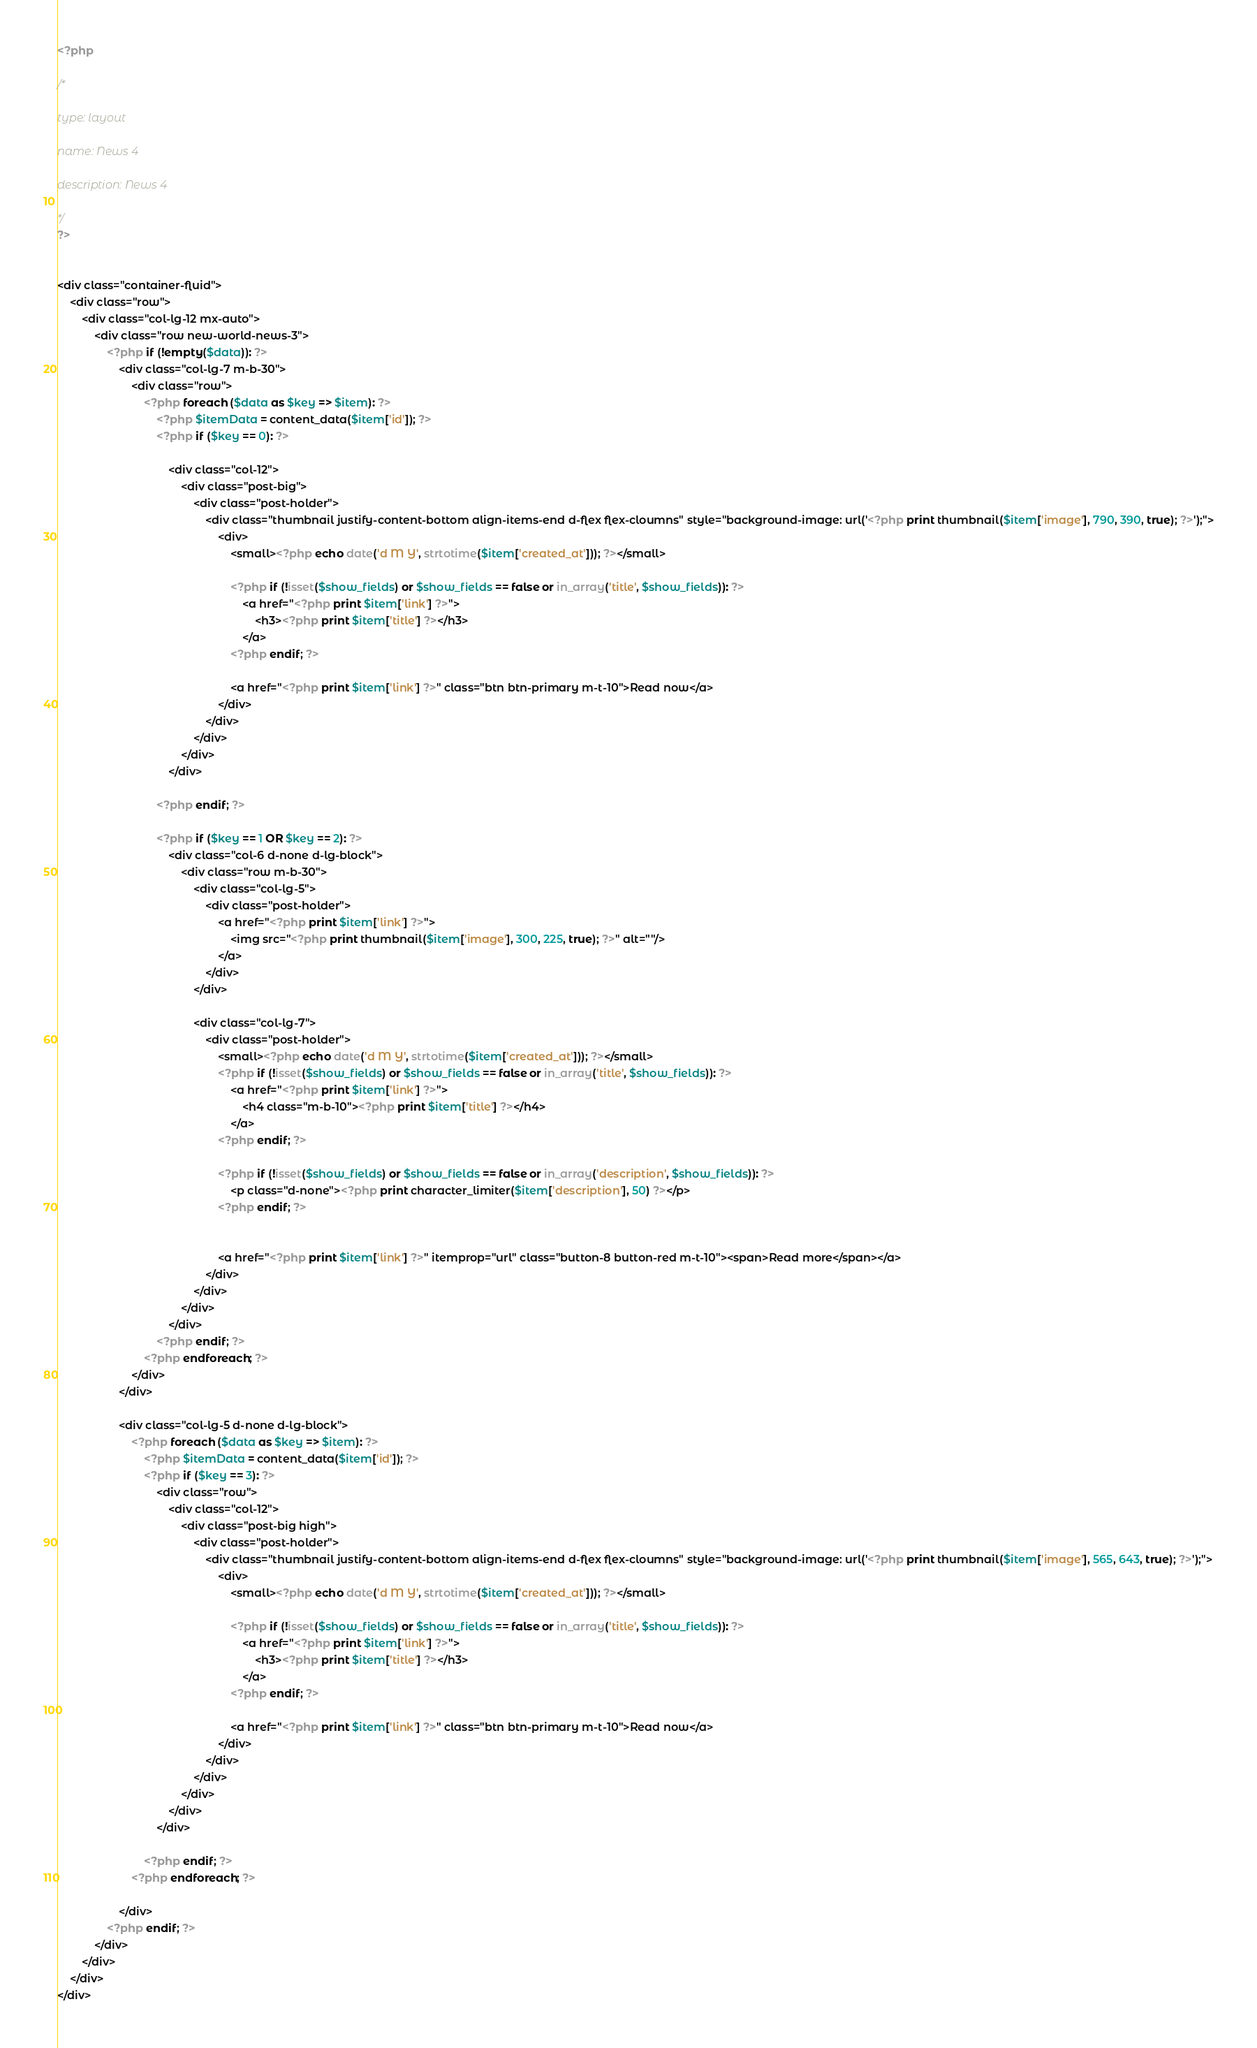Convert code to text. <code><loc_0><loc_0><loc_500><loc_500><_PHP_><?php

/*

type: layout

name: News 4

description: News 4

*/
?>


<div class="container-fluid">
    <div class="row">
        <div class="col-lg-12 mx-auto">
            <div class="row new-world-news-3">
                <?php if (!empty($data)): ?>
                    <div class="col-lg-7 m-b-30">
                        <div class="row">
                            <?php foreach ($data as $key => $item): ?>
                                <?php $itemData = content_data($item['id']); ?>
                                <?php if ($key == 0): ?>

                                    <div class="col-12">
                                        <div class="post-big">
                                            <div class="post-holder">
                                                <div class="thumbnail justify-content-bottom align-items-end d-flex flex-cloumns" style="background-image: url('<?php print thumbnail($item['image'], 790, 390, true); ?>');">
                                                    <div>
                                                        <small><?php echo date('d M Y', strtotime($item['created_at'])); ?></small>

                                                        <?php if (!isset($show_fields) or $show_fields == false or in_array('title', $show_fields)): ?>
                                                            <a href="<?php print $item['link'] ?>">
                                                                <h3><?php print $item['title'] ?></h3>
                                                            </a>
                                                        <?php endif; ?>

                                                        <a href="<?php print $item['link'] ?>" class="btn btn-primary m-t-10">Read now</a>
                                                    </div>
                                                </div>
                                            </div>
                                        </div>
                                    </div>

                                <?php endif; ?>

                                <?php if ($key == 1 OR $key == 2): ?>
                                    <div class="col-6 d-none d-lg-block">
                                        <div class="row m-b-30">
                                            <div class="col-lg-5">
                                                <div class="post-holder">
                                                    <a href="<?php print $item['link'] ?>">
                                                        <img src="<?php print thumbnail($item['image'], 300, 225, true); ?>" alt=""/>
                                                    </a>
                                                </div>
                                            </div>

                                            <div class="col-lg-7">
                                                <div class="post-holder">
                                                    <small><?php echo date('d M Y', strtotime($item['created_at'])); ?></small>
                                                    <?php if (!isset($show_fields) or $show_fields == false or in_array('title', $show_fields)): ?>
                                                        <a href="<?php print $item['link'] ?>">
                                                            <h4 class="m-b-10"><?php print $item['title'] ?></h4>
                                                        </a>
                                                    <?php endif; ?>

                                                    <?php if (!isset($show_fields) or $show_fields == false or in_array('description', $show_fields)): ?>
                                                        <p class="d-none"><?php print character_limiter($item['description'], 50) ?></p>
                                                    <?php endif; ?>


                                                    <a href="<?php print $item['link'] ?>" itemprop="url" class="button-8 button-red m-t-10"><span>Read more</span></a>
                                                </div>
                                            </div>
                                        </div>
                                    </div>
                                <?php endif; ?>
                            <?php endforeach; ?>
                        </div>
                    </div>

                    <div class="col-lg-5 d-none d-lg-block">
                        <?php foreach ($data as $key => $item): ?>
                            <?php $itemData = content_data($item['id']); ?>
                            <?php if ($key == 3): ?>
                                <div class="row">
                                    <div class="col-12">
                                        <div class="post-big high">
                                            <div class="post-holder">
                                                <div class="thumbnail justify-content-bottom align-items-end d-flex flex-cloumns" style="background-image: url('<?php print thumbnail($item['image'], 565, 643, true); ?>');">
                                                    <div>
                                                        <small><?php echo date('d M Y', strtotime($item['created_at'])); ?></small>

                                                        <?php if (!isset($show_fields) or $show_fields == false or in_array('title', $show_fields)): ?>
                                                            <a href="<?php print $item['link'] ?>">
                                                                <h3><?php print $item['title'] ?></h3>
                                                            </a>
                                                        <?php endif; ?>

                                                        <a href="<?php print $item['link'] ?>" class="btn btn-primary m-t-10">Read now</a>
                                                    </div>
                                                </div>
                                            </div>
                                        </div>
                                    </div>
                                </div>

                            <?php endif; ?>
                        <?php endforeach; ?>

                    </div>
                <?php endif; ?>
            </div>
        </div>
    </div>
</div>

</code> 